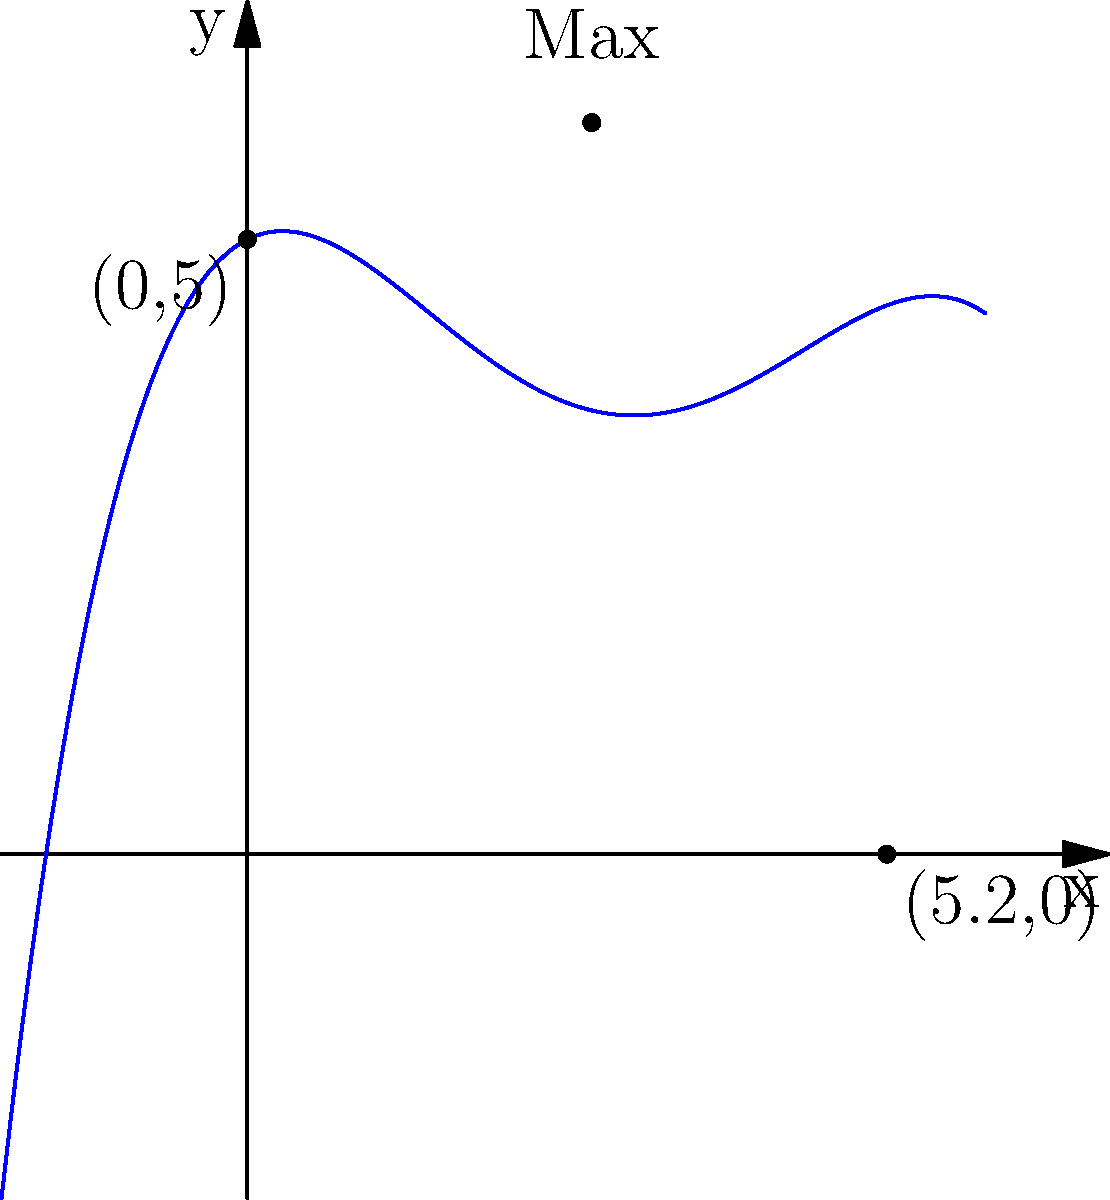As an urban planner working on a revitalization project in Buenos Aires, you're designing a pedestrian bridge over a canal. The bridge's shape can be modeled by the polynomial function $f(x) = -0.025x^4 + 0.3x^3 - x^2 + 0.5x + 5$, where $x$ is the horizontal distance in meters and $f(x)$ is the height in meters. What is the maximum height of the bridge, and at what horizontal distance does it occur? To find the maximum height of the bridge and its corresponding horizontal distance, we need to follow these steps:

1) The maximum point of the function occurs where its derivative equals zero. Let's find the derivative:

   $f'(x) = -0.1x^3 + 0.9x^2 - 2x + 0.5$

2) Set $f'(x) = 0$ and solve for x:

   $-0.1x^3 + 0.9x^2 - 2x + 0.5 = 0$

3) This cubic equation is difficult to solve by hand. Using a graphing calculator or computer algebra system, we find that the solution closest to the visible maximum is approximately $x = 2.8$ meters.

4) To find the maximum height, we plug this x-value back into our original function:

   $f(2.8) = -0.025(2.8)^4 + 0.3(2.8)^3 - (2.8)^2 + 0.5(2.8) + 5$

5) Calculating this gives us approximately 5.95 meters.

Therefore, the maximum height of the bridge is about 5.95 meters, occurring at a horizontal distance of approximately 2.8 meters from the starting point.
Answer: Maximum height: 5.95 m at x = 2.8 m 